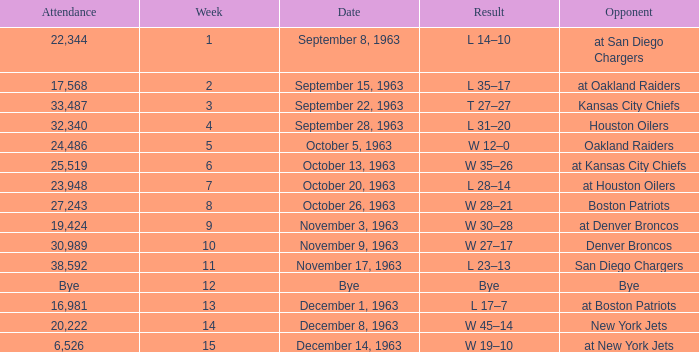Would you mind parsing the complete table? {'header': ['Attendance', 'Week', 'Date', 'Result', 'Opponent'], 'rows': [['22,344', '1', 'September 8, 1963', 'L 14–10', 'at San Diego Chargers'], ['17,568', '2', 'September 15, 1963', 'L 35–17', 'at Oakland Raiders'], ['33,487', '3', 'September 22, 1963', 'T 27–27', 'Kansas City Chiefs'], ['32,340', '4', 'September 28, 1963', 'L 31–20', 'Houston Oilers'], ['24,486', '5', 'October 5, 1963', 'W 12–0', 'Oakland Raiders'], ['25,519', '6', 'October 13, 1963', 'W 35–26', 'at Kansas City Chiefs'], ['23,948', '7', 'October 20, 1963', 'L 28–14', 'at Houston Oilers'], ['27,243', '8', 'October 26, 1963', 'W 28–21', 'Boston Patriots'], ['19,424', '9', 'November 3, 1963', 'W 30–28', 'at Denver Broncos'], ['30,989', '10', 'November 9, 1963', 'W 27–17', 'Denver Broncos'], ['38,592', '11', 'November 17, 1963', 'L 23–13', 'San Diego Chargers'], ['Bye', '12', 'Bye', 'Bye', 'Bye'], ['16,981', '13', 'December 1, 1963', 'L 17–7', 'at Boston Patriots'], ['20,222', '14', 'December 8, 1963', 'W 45–14', 'New York Jets'], ['6,526', '15', 'December 14, 1963', 'W 19–10', 'at New York Jets']]} Which Opponent has a Result of l 14–10? At san diego chargers. 